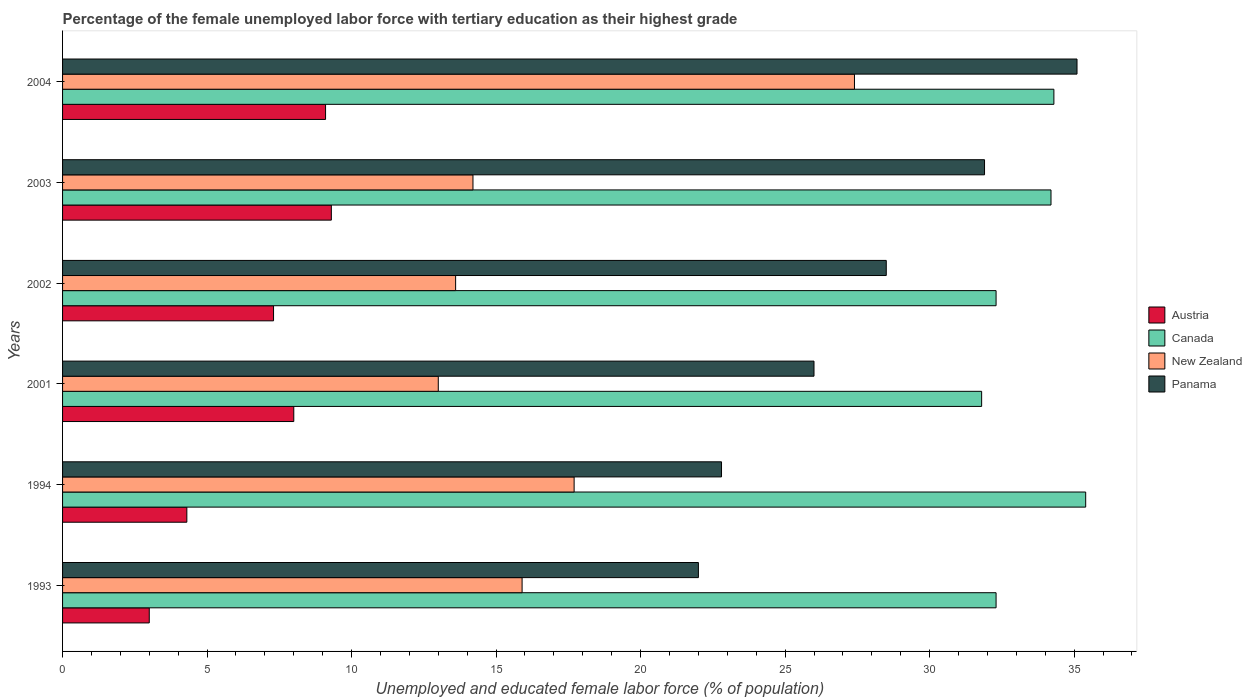How many different coloured bars are there?
Your answer should be compact. 4. Across all years, what is the maximum percentage of the unemployed female labor force with tertiary education in Canada?
Give a very brief answer. 35.4. What is the total percentage of the unemployed female labor force with tertiary education in Austria in the graph?
Offer a terse response. 41. What is the difference between the percentage of the unemployed female labor force with tertiary education in Austria in 2004 and the percentage of the unemployed female labor force with tertiary education in New Zealand in 1994?
Keep it short and to the point. -8.6. What is the average percentage of the unemployed female labor force with tertiary education in Austria per year?
Your response must be concise. 6.83. In the year 1993, what is the difference between the percentage of the unemployed female labor force with tertiary education in Panama and percentage of the unemployed female labor force with tertiary education in Canada?
Ensure brevity in your answer.  -10.3. In how many years, is the percentage of the unemployed female labor force with tertiary education in Austria greater than 18 %?
Provide a short and direct response. 0. What is the ratio of the percentage of the unemployed female labor force with tertiary education in Austria in 2002 to that in 2003?
Your response must be concise. 0.78. Is the percentage of the unemployed female labor force with tertiary education in New Zealand in 2001 less than that in 2002?
Ensure brevity in your answer.  Yes. What is the difference between the highest and the second highest percentage of the unemployed female labor force with tertiary education in Austria?
Your response must be concise. 0.2. What is the difference between the highest and the lowest percentage of the unemployed female labor force with tertiary education in Austria?
Provide a short and direct response. 6.3. Is it the case that in every year, the sum of the percentage of the unemployed female labor force with tertiary education in New Zealand and percentage of the unemployed female labor force with tertiary education in Panama is greater than the sum of percentage of the unemployed female labor force with tertiary education in Austria and percentage of the unemployed female labor force with tertiary education in Canada?
Offer a very short reply. No. What does the 1st bar from the bottom in 2002 represents?
Make the answer very short. Austria. Is it the case that in every year, the sum of the percentage of the unemployed female labor force with tertiary education in Canada and percentage of the unemployed female labor force with tertiary education in Panama is greater than the percentage of the unemployed female labor force with tertiary education in Austria?
Your response must be concise. Yes. How many bars are there?
Offer a terse response. 24. Are all the bars in the graph horizontal?
Your answer should be very brief. Yes. What is the difference between two consecutive major ticks on the X-axis?
Provide a short and direct response. 5. What is the title of the graph?
Offer a very short reply. Percentage of the female unemployed labor force with tertiary education as their highest grade. Does "Nicaragua" appear as one of the legend labels in the graph?
Give a very brief answer. No. What is the label or title of the X-axis?
Give a very brief answer. Unemployed and educated female labor force (% of population). What is the Unemployed and educated female labor force (% of population) of Canada in 1993?
Keep it short and to the point. 32.3. What is the Unemployed and educated female labor force (% of population) of New Zealand in 1993?
Keep it short and to the point. 15.9. What is the Unemployed and educated female labor force (% of population) of Austria in 1994?
Provide a succinct answer. 4.3. What is the Unemployed and educated female labor force (% of population) in Canada in 1994?
Ensure brevity in your answer.  35.4. What is the Unemployed and educated female labor force (% of population) of New Zealand in 1994?
Provide a succinct answer. 17.7. What is the Unemployed and educated female labor force (% of population) of Panama in 1994?
Ensure brevity in your answer.  22.8. What is the Unemployed and educated female labor force (% of population) in Austria in 2001?
Your answer should be compact. 8. What is the Unemployed and educated female labor force (% of population) in Canada in 2001?
Your answer should be compact. 31.8. What is the Unemployed and educated female labor force (% of population) of Austria in 2002?
Provide a succinct answer. 7.3. What is the Unemployed and educated female labor force (% of population) in Canada in 2002?
Give a very brief answer. 32.3. What is the Unemployed and educated female labor force (% of population) of New Zealand in 2002?
Give a very brief answer. 13.6. What is the Unemployed and educated female labor force (% of population) in Austria in 2003?
Your answer should be very brief. 9.3. What is the Unemployed and educated female labor force (% of population) of Canada in 2003?
Give a very brief answer. 34.2. What is the Unemployed and educated female labor force (% of population) in New Zealand in 2003?
Make the answer very short. 14.2. What is the Unemployed and educated female labor force (% of population) in Panama in 2003?
Provide a succinct answer. 31.9. What is the Unemployed and educated female labor force (% of population) of Austria in 2004?
Offer a very short reply. 9.1. What is the Unemployed and educated female labor force (% of population) of Canada in 2004?
Your answer should be very brief. 34.3. What is the Unemployed and educated female labor force (% of population) of New Zealand in 2004?
Make the answer very short. 27.4. What is the Unemployed and educated female labor force (% of population) in Panama in 2004?
Give a very brief answer. 35.1. Across all years, what is the maximum Unemployed and educated female labor force (% of population) in Austria?
Your response must be concise. 9.3. Across all years, what is the maximum Unemployed and educated female labor force (% of population) of Canada?
Make the answer very short. 35.4. Across all years, what is the maximum Unemployed and educated female labor force (% of population) in New Zealand?
Offer a very short reply. 27.4. Across all years, what is the maximum Unemployed and educated female labor force (% of population) in Panama?
Offer a very short reply. 35.1. Across all years, what is the minimum Unemployed and educated female labor force (% of population) of Austria?
Offer a terse response. 3. Across all years, what is the minimum Unemployed and educated female labor force (% of population) in Canada?
Your response must be concise. 31.8. Across all years, what is the minimum Unemployed and educated female labor force (% of population) in New Zealand?
Offer a terse response. 13. What is the total Unemployed and educated female labor force (% of population) in Canada in the graph?
Your answer should be compact. 200.3. What is the total Unemployed and educated female labor force (% of population) in New Zealand in the graph?
Your answer should be very brief. 101.8. What is the total Unemployed and educated female labor force (% of population) in Panama in the graph?
Your answer should be compact. 166.3. What is the difference between the Unemployed and educated female labor force (% of population) in Canada in 1993 and that in 1994?
Make the answer very short. -3.1. What is the difference between the Unemployed and educated female labor force (% of population) in New Zealand in 1993 and that in 1994?
Provide a short and direct response. -1.8. What is the difference between the Unemployed and educated female labor force (% of population) of Panama in 1993 and that in 1994?
Ensure brevity in your answer.  -0.8. What is the difference between the Unemployed and educated female labor force (% of population) of Canada in 1993 and that in 2001?
Your answer should be compact. 0.5. What is the difference between the Unemployed and educated female labor force (% of population) of Austria in 1993 and that in 2003?
Keep it short and to the point. -6.3. What is the difference between the Unemployed and educated female labor force (% of population) in Canada in 1993 and that in 2003?
Provide a short and direct response. -1.9. What is the difference between the Unemployed and educated female labor force (% of population) of Austria in 1993 and that in 2004?
Your response must be concise. -6.1. What is the difference between the Unemployed and educated female labor force (% of population) of Canada in 1993 and that in 2004?
Provide a succinct answer. -2. What is the difference between the Unemployed and educated female labor force (% of population) of New Zealand in 1993 and that in 2004?
Provide a succinct answer. -11.5. What is the difference between the Unemployed and educated female labor force (% of population) in Austria in 1994 and that in 2001?
Your answer should be very brief. -3.7. What is the difference between the Unemployed and educated female labor force (% of population) in Canada in 1994 and that in 2001?
Your answer should be very brief. 3.6. What is the difference between the Unemployed and educated female labor force (% of population) in New Zealand in 1994 and that in 2001?
Offer a very short reply. 4.7. What is the difference between the Unemployed and educated female labor force (% of population) of Canada in 1994 and that in 2002?
Provide a short and direct response. 3.1. What is the difference between the Unemployed and educated female labor force (% of population) of Austria in 1994 and that in 2003?
Offer a terse response. -5. What is the difference between the Unemployed and educated female labor force (% of population) of Canada in 1994 and that in 2003?
Keep it short and to the point. 1.2. What is the difference between the Unemployed and educated female labor force (% of population) in New Zealand in 1994 and that in 2003?
Offer a very short reply. 3.5. What is the difference between the Unemployed and educated female labor force (% of population) of Panama in 1994 and that in 2004?
Your answer should be compact. -12.3. What is the difference between the Unemployed and educated female labor force (% of population) of Panama in 2001 and that in 2002?
Offer a terse response. -2.5. What is the difference between the Unemployed and educated female labor force (% of population) of New Zealand in 2001 and that in 2003?
Make the answer very short. -1.2. What is the difference between the Unemployed and educated female labor force (% of population) of Panama in 2001 and that in 2003?
Your response must be concise. -5.9. What is the difference between the Unemployed and educated female labor force (% of population) of New Zealand in 2001 and that in 2004?
Your answer should be compact. -14.4. What is the difference between the Unemployed and educated female labor force (% of population) of Austria in 2002 and that in 2003?
Offer a very short reply. -2. What is the difference between the Unemployed and educated female labor force (% of population) of Canada in 2002 and that in 2003?
Your response must be concise. -1.9. What is the difference between the Unemployed and educated female labor force (% of population) of Panama in 2002 and that in 2003?
Provide a short and direct response. -3.4. What is the difference between the Unemployed and educated female labor force (% of population) of Austria in 2003 and that in 2004?
Offer a terse response. 0.2. What is the difference between the Unemployed and educated female labor force (% of population) of Canada in 2003 and that in 2004?
Your answer should be very brief. -0.1. What is the difference between the Unemployed and educated female labor force (% of population) of New Zealand in 2003 and that in 2004?
Offer a terse response. -13.2. What is the difference between the Unemployed and educated female labor force (% of population) in Austria in 1993 and the Unemployed and educated female labor force (% of population) in Canada in 1994?
Ensure brevity in your answer.  -32.4. What is the difference between the Unemployed and educated female labor force (% of population) in Austria in 1993 and the Unemployed and educated female labor force (% of population) in New Zealand in 1994?
Provide a succinct answer. -14.7. What is the difference between the Unemployed and educated female labor force (% of population) in Austria in 1993 and the Unemployed and educated female labor force (% of population) in Panama in 1994?
Make the answer very short. -19.8. What is the difference between the Unemployed and educated female labor force (% of population) in Canada in 1993 and the Unemployed and educated female labor force (% of population) in Panama in 1994?
Your answer should be very brief. 9.5. What is the difference between the Unemployed and educated female labor force (% of population) of Austria in 1993 and the Unemployed and educated female labor force (% of population) of Canada in 2001?
Provide a short and direct response. -28.8. What is the difference between the Unemployed and educated female labor force (% of population) in Austria in 1993 and the Unemployed and educated female labor force (% of population) in Panama in 2001?
Your response must be concise. -23. What is the difference between the Unemployed and educated female labor force (% of population) of Canada in 1993 and the Unemployed and educated female labor force (% of population) of New Zealand in 2001?
Offer a terse response. 19.3. What is the difference between the Unemployed and educated female labor force (% of population) in Canada in 1993 and the Unemployed and educated female labor force (% of population) in Panama in 2001?
Give a very brief answer. 6.3. What is the difference between the Unemployed and educated female labor force (% of population) in Austria in 1993 and the Unemployed and educated female labor force (% of population) in Canada in 2002?
Provide a succinct answer. -29.3. What is the difference between the Unemployed and educated female labor force (% of population) of Austria in 1993 and the Unemployed and educated female labor force (% of population) of New Zealand in 2002?
Your answer should be compact. -10.6. What is the difference between the Unemployed and educated female labor force (% of population) in Austria in 1993 and the Unemployed and educated female labor force (% of population) in Panama in 2002?
Offer a very short reply. -25.5. What is the difference between the Unemployed and educated female labor force (% of population) in New Zealand in 1993 and the Unemployed and educated female labor force (% of population) in Panama in 2002?
Keep it short and to the point. -12.6. What is the difference between the Unemployed and educated female labor force (% of population) in Austria in 1993 and the Unemployed and educated female labor force (% of population) in Canada in 2003?
Provide a succinct answer. -31.2. What is the difference between the Unemployed and educated female labor force (% of population) in Austria in 1993 and the Unemployed and educated female labor force (% of population) in Panama in 2003?
Keep it short and to the point. -28.9. What is the difference between the Unemployed and educated female labor force (% of population) of Austria in 1993 and the Unemployed and educated female labor force (% of population) of Canada in 2004?
Your answer should be compact. -31.3. What is the difference between the Unemployed and educated female labor force (% of population) in Austria in 1993 and the Unemployed and educated female labor force (% of population) in New Zealand in 2004?
Your answer should be compact. -24.4. What is the difference between the Unemployed and educated female labor force (% of population) in Austria in 1993 and the Unemployed and educated female labor force (% of population) in Panama in 2004?
Your answer should be compact. -32.1. What is the difference between the Unemployed and educated female labor force (% of population) in Canada in 1993 and the Unemployed and educated female labor force (% of population) in New Zealand in 2004?
Your answer should be compact. 4.9. What is the difference between the Unemployed and educated female labor force (% of population) in New Zealand in 1993 and the Unemployed and educated female labor force (% of population) in Panama in 2004?
Make the answer very short. -19.2. What is the difference between the Unemployed and educated female labor force (% of population) in Austria in 1994 and the Unemployed and educated female labor force (% of population) in Canada in 2001?
Offer a very short reply. -27.5. What is the difference between the Unemployed and educated female labor force (% of population) of Austria in 1994 and the Unemployed and educated female labor force (% of population) of Panama in 2001?
Ensure brevity in your answer.  -21.7. What is the difference between the Unemployed and educated female labor force (% of population) in Canada in 1994 and the Unemployed and educated female labor force (% of population) in New Zealand in 2001?
Offer a terse response. 22.4. What is the difference between the Unemployed and educated female labor force (% of population) of New Zealand in 1994 and the Unemployed and educated female labor force (% of population) of Panama in 2001?
Offer a terse response. -8.3. What is the difference between the Unemployed and educated female labor force (% of population) of Austria in 1994 and the Unemployed and educated female labor force (% of population) of New Zealand in 2002?
Offer a terse response. -9.3. What is the difference between the Unemployed and educated female labor force (% of population) in Austria in 1994 and the Unemployed and educated female labor force (% of population) in Panama in 2002?
Keep it short and to the point. -24.2. What is the difference between the Unemployed and educated female labor force (% of population) in Canada in 1994 and the Unemployed and educated female labor force (% of population) in New Zealand in 2002?
Offer a very short reply. 21.8. What is the difference between the Unemployed and educated female labor force (% of population) of Canada in 1994 and the Unemployed and educated female labor force (% of population) of Panama in 2002?
Your response must be concise. 6.9. What is the difference between the Unemployed and educated female labor force (% of population) of Austria in 1994 and the Unemployed and educated female labor force (% of population) of Canada in 2003?
Provide a succinct answer. -29.9. What is the difference between the Unemployed and educated female labor force (% of population) of Austria in 1994 and the Unemployed and educated female labor force (% of population) of Panama in 2003?
Your answer should be very brief. -27.6. What is the difference between the Unemployed and educated female labor force (% of population) in Canada in 1994 and the Unemployed and educated female labor force (% of population) in New Zealand in 2003?
Ensure brevity in your answer.  21.2. What is the difference between the Unemployed and educated female labor force (% of population) in Canada in 1994 and the Unemployed and educated female labor force (% of population) in Panama in 2003?
Offer a very short reply. 3.5. What is the difference between the Unemployed and educated female labor force (% of population) of Austria in 1994 and the Unemployed and educated female labor force (% of population) of New Zealand in 2004?
Your answer should be very brief. -23.1. What is the difference between the Unemployed and educated female labor force (% of population) of Austria in 1994 and the Unemployed and educated female labor force (% of population) of Panama in 2004?
Your answer should be compact. -30.8. What is the difference between the Unemployed and educated female labor force (% of population) in Canada in 1994 and the Unemployed and educated female labor force (% of population) in Panama in 2004?
Ensure brevity in your answer.  0.3. What is the difference between the Unemployed and educated female labor force (% of population) of New Zealand in 1994 and the Unemployed and educated female labor force (% of population) of Panama in 2004?
Provide a succinct answer. -17.4. What is the difference between the Unemployed and educated female labor force (% of population) of Austria in 2001 and the Unemployed and educated female labor force (% of population) of Canada in 2002?
Your response must be concise. -24.3. What is the difference between the Unemployed and educated female labor force (% of population) in Austria in 2001 and the Unemployed and educated female labor force (% of population) in Panama in 2002?
Your answer should be compact. -20.5. What is the difference between the Unemployed and educated female labor force (% of population) in Canada in 2001 and the Unemployed and educated female labor force (% of population) in Panama in 2002?
Make the answer very short. 3.3. What is the difference between the Unemployed and educated female labor force (% of population) in New Zealand in 2001 and the Unemployed and educated female labor force (% of population) in Panama in 2002?
Ensure brevity in your answer.  -15.5. What is the difference between the Unemployed and educated female labor force (% of population) in Austria in 2001 and the Unemployed and educated female labor force (% of population) in Canada in 2003?
Provide a succinct answer. -26.2. What is the difference between the Unemployed and educated female labor force (% of population) in Austria in 2001 and the Unemployed and educated female labor force (% of population) in New Zealand in 2003?
Your response must be concise. -6.2. What is the difference between the Unemployed and educated female labor force (% of population) of Austria in 2001 and the Unemployed and educated female labor force (% of population) of Panama in 2003?
Offer a terse response. -23.9. What is the difference between the Unemployed and educated female labor force (% of population) of Canada in 2001 and the Unemployed and educated female labor force (% of population) of New Zealand in 2003?
Offer a terse response. 17.6. What is the difference between the Unemployed and educated female labor force (% of population) in New Zealand in 2001 and the Unemployed and educated female labor force (% of population) in Panama in 2003?
Your answer should be compact. -18.9. What is the difference between the Unemployed and educated female labor force (% of population) in Austria in 2001 and the Unemployed and educated female labor force (% of population) in Canada in 2004?
Ensure brevity in your answer.  -26.3. What is the difference between the Unemployed and educated female labor force (% of population) in Austria in 2001 and the Unemployed and educated female labor force (% of population) in New Zealand in 2004?
Your answer should be compact. -19.4. What is the difference between the Unemployed and educated female labor force (% of population) of Austria in 2001 and the Unemployed and educated female labor force (% of population) of Panama in 2004?
Give a very brief answer. -27.1. What is the difference between the Unemployed and educated female labor force (% of population) in Canada in 2001 and the Unemployed and educated female labor force (% of population) in Panama in 2004?
Keep it short and to the point. -3.3. What is the difference between the Unemployed and educated female labor force (% of population) in New Zealand in 2001 and the Unemployed and educated female labor force (% of population) in Panama in 2004?
Keep it short and to the point. -22.1. What is the difference between the Unemployed and educated female labor force (% of population) in Austria in 2002 and the Unemployed and educated female labor force (% of population) in Canada in 2003?
Keep it short and to the point. -26.9. What is the difference between the Unemployed and educated female labor force (% of population) of Austria in 2002 and the Unemployed and educated female labor force (% of population) of Panama in 2003?
Your answer should be very brief. -24.6. What is the difference between the Unemployed and educated female labor force (% of population) of Canada in 2002 and the Unemployed and educated female labor force (% of population) of New Zealand in 2003?
Offer a very short reply. 18.1. What is the difference between the Unemployed and educated female labor force (% of population) in New Zealand in 2002 and the Unemployed and educated female labor force (% of population) in Panama in 2003?
Ensure brevity in your answer.  -18.3. What is the difference between the Unemployed and educated female labor force (% of population) in Austria in 2002 and the Unemployed and educated female labor force (% of population) in New Zealand in 2004?
Your response must be concise. -20.1. What is the difference between the Unemployed and educated female labor force (% of population) of Austria in 2002 and the Unemployed and educated female labor force (% of population) of Panama in 2004?
Provide a succinct answer. -27.8. What is the difference between the Unemployed and educated female labor force (% of population) in Canada in 2002 and the Unemployed and educated female labor force (% of population) in Panama in 2004?
Keep it short and to the point. -2.8. What is the difference between the Unemployed and educated female labor force (% of population) of New Zealand in 2002 and the Unemployed and educated female labor force (% of population) of Panama in 2004?
Offer a terse response. -21.5. What is the difference between the Unemployed and educated female labor force (% of population) in Austria in 2003 and the Unemployed and educated female labor force (% of population) in New Zealand in 2004?
Your answer should be compact. -18.1. What is the difference between the Unemployed and educated female labor force (% of population) in Austria in 2003 and the Unemployed and educated female labor force (% of population) in Panama in 2004?
Provide a short and direct response. -25.8. What is the difference between the Unemployed and educated female labor force (% of population) of Canada in 2003 and the Unemployed and educated female labor force (% of population) of Panama in 2004?
Offer a terse response. -0.9. What is the difference between the Unemployed and educated female labor force (% of population) in New Zealand in 2003 and the Unemployed and educated female labor force (% of population) in Panama in 2004?
Your response must be concise. -20.9. What is the average Unemployed and educated female labor force (% of population) of Austria per year?
Your answer should be very brief. 6.83. What is the average Unemployed and educated female labor force (% of population) in Canada per year?
Offer a very short reply. 33.38. What is the average Unemployed and educated female labor force (% of population) of New Zealand per year?
Offer a terse response. 16.97. What is the average Unemployed and educated female labor force (% of population) of Panama per year?
Offer a terse response. 27.72. In the year 1993, what is the difference between the Unemployed and educated female labor force (% of population) in Austria and Unemployed and educated female labor force (% of population) in Canada?
Provide a short and direct response. -29.3. In the year 1993, what is the difference between the Unemployed and educated female labor force (% of population) of Canada and Unemployed and educated female labor force (% of population) of New Zealand?
Keep it short and to the point. 16.4. In the year 1993, what is the difference between the Unemployed and educated female labor force (% of population) of New Zealand and Unemployed and educated female labor force (% of population) of Panama?
Keep it short and to the point. -6.1. In the year 1994, what is the difference between the Unemployed and educated female labor force (% of population) of Austria and Unemployed and educated female labor force (% of population) of Canada?
Give a very brief answer. -31.1. In the year 1994, what is the difference between the Unemployed and educated female labor force (% of population) in Austria and Unemployed and educated female labor force (% of population) in Panama?
Make the answer very short. -18.5. In the year 1994, what is the difference between the Unemployed and educated female labor force (% of population) of Canada and Unemployed and educated female labor force (% of population) of Panama?
Your answer should be compact. 12.6. In the year 2001, what is the difference between the Unemployed and educated female labor force (% of population) in Austria and Unemployed and educated female labor force (% of population) in Canada?
Give a very brief answer. -23.8. In the year 2001, what is the difference between the Unemployed and educated female labor force (% of population) in Austria and Unemployed and educated female labor force (% of population) in Panama?
Make the answer very short. -18. In the year 2001, what is the difference between the Unemployed and educated female labor force (% of population) of Canada and Unemployed and educated female labor force (% of population) of New Zealand?
Your answer should be compact. 18.8. In the year 2001, what is the difference between the Unemployed and educated female labor force (% of population) of New Zealand and Unemployed and educated female labor force (% of population) of Panama?
Give a very brief answer. -13. In the year 2002, what is the difference between the Unemployed and educated female labor force (% of population) in Austria and Unemployed and educated female labor force (% of population) in Canada?
Give a very brief answer. -25. In the year 2002, what is the difference between the Unemployed and educated female labor force (% of population) in Austria and Unemployed and educated female labor force (% of population) in Panama?
Your answer should be very brief. -21.2. In the year 2002, what is the difference between the Unemployed and educated female labor force (% of population) of New Zealand and Unemployed and educated female labor force (% of population) of Panama?
Your response must be concise. -14.9. In the year 2003, what is the difference between the Unemployed and educated female labor force (% of population) of Austria and Unemployed and educated female labor force (% of population) of Canada?
Provide a succinct answer. -24.9. In the year 2003, what is the difference between the Unemployed and educated female labor force (% of population) in Austria and Unemployed and educated female labor force (% of population) in Panama?
Your answer should be very brief. -22.6. In the year 2003, what is the difference between the Unemployed and educated female labor force (% of population) of New Zealand and Unemployed and educated female labor force (% of population) of Panama?
Make the answer very short. -17.7. In the year 2004, what is the difference between the Unemployed and educated female labor force (% of population) of Austria and Unemployed and educated female labor force (% of population) of Canada?
Ensure brevity in your answer.  -25.2. In the year 2004, what is the difference between the Unemployed and educated female labor force (% of population) of Austria and Unemployed and educated female labor force (% of population) of New Zealand?
Provide a short and direct response. -18.3. In the year 2004, what is the difference between the Unemployed and educated female labor force (% of population) of Austria and Unemployed and educated female labor force (% of population) of Panama?
Provide a short and direct response. -26. In the year 2004, what is the difference between the Unemployed and educated female labor force (% of population) in Canada and Unemployed and educated female labor force (% of population) in New Zealand?
Make the answer very short. 6.9. In the year 2004, what is the difference between the Unemployed and educated female labor force (% of population) of Canada and Unemployed and educated female labor force (% of population) of Panama?
Ensure brevity in your answer.  -0.8. In the year 2004, what is the difference between the Unemployed and educated female labor force (% of population) of New Zealand and Unemployed and educated female labor force (% of population) of Panama?
Provide a short and direct response. -7.7. What is the ratio of the Unemployed and educated female labor force (% of population) in Austria in 1993 to that in 1994?
Provide a short and direct response. 0.7. What is the ratio of the Unemployed and educated female labor force (% of population) of Canada in 1993 to that in 1994?
Keep it short and to the point. 0.91. What is the ratio of the Unemployed and educated female labor force (% of population) of New Zealand in 1993 to that in 1994?
Your answer should be very brief. 0.9. What is the ratio of the Unemployed and educated female labor force (% of population) of Panama in 1993 to that in 1994?
Keep it short and to the point. 0.96. What is the ratio of the Unemployed and educated female labor force (% of population) in Canada in 1993 to that in 2001?
Ensure brevity in your answer.  1.02. What is the ratio of the Unemployed and educated female labor force (% of population) of New Zealand in 1993 to that in 2001?
Keep it short and to the point. 1.22. What is the ratio of the Unemployed and educated female labor force (% of population) in Panama in 1993 to that in 2001?
Give a very brief answer. 0.85. What is the ratio of the Unemployed and educated female labor force (% of population) in Austria in 1993 to that in 2002?
Provide a succinct answer. 0.41. What is the ratio of the Unemployed and educated female labor force (% of population) in Canada in 1993 to that in 2002?
Your answer should be very brief. 1. What is the ratio of the Unemployed and educated female labor force (% of population) of New Zealand in 1993 to that in 2002?
Provide a succinct answer. 1.17. What is the ratio of the Unemployed and educated female labor force (% of population) of Panama in 1993 to that in 2002?
Keep it short and to the point. 0.77. What is the ratio of the Unemployed and educated female labor force (% of population) of Austria in 1993 to that in 2003?
Provide a short and direct response. 0.32. What is the ratio of the Unemployed and educated female labor force (% of population) of New Zealand in 1993 to that in 2003?
Keep it short and to the point. 1.12. What is the ratio of the Unemployed and educated female labor force (% of population) of Panama in 1993 to that in 2003?
Provide a succinct answer. 0.69. What is the ratio of the Unemployed and educated female labor force (% of population) of Austria in 1993 to that in 2004?
Give a very brief answer. 0.33. What is the ratio of the Unemployed and educated female labor force (% of population) of Canada in 1993 to that in 2004?
Your answer should be compact. 0.94. What is the ratio of the Unemployed and educated female labor force (% of population) in New Zealand in 1993 to that in 2004?
Your answer should be compact. 0.58. What is the ratio of the Unemployed and educated female labor force (% of population) of Panama in 1993 to that in 2004?
Provide a succinct answer. 0.63. What is the ratio of the Unemployed and educated female labor force (% of population) in Austria in 1994 to that in 2001?
Keep it short and to the point. 0.54. What is the ratio of the Unemployed and educated female labor force (% of population) in Canada in 1994 to that in 2001?
Your answer should be very brief. 1.11. What is the ratio of the Unemployed and educated female labor force (% of population) in New Zealand in 1994 to that in 2001?
Ensure brevity in your answer.  1.36. What is the ratio of the Unemployed and educated female labor force (% of population) in Panama in 1994 to that in 2001?
Offer a very short reply. 0.88. What is the ratio of the Unemployed and educated female labor force (% of population) in Austria in 1994 to that in 2002?
Ensure brevity in your answer.  0.59. What is the ratio of the Unemployed and educated female labor force (% of population) of Canada in 1994 to that in 2002?
Offer a very short reply. 1.1. What is the ratio of the Unemployed and educated female labor force (% of population) of New Zealand in 1994 to that in 2002?
Offer a terse response. 1.3. What is the ratio of the Unemployed and educated female labor force (% of population) in Austria in 1994 to that in 2003?
Your answer should be compact. 0.46. What is the ratio of the Unemployed and educated female labor force (% of population) of Canada in 1994 to that in 2003?
Give a very brief answer. 1.04. What is the ratio of the Unemployed and educated female labor force (% of population) of New Zealand in 1994 to that in 2003?
Your response must be concise. 1.25. What is the ratio of the Unemployed and educated female labor force (% of population) in Panama in 1994 to that in 2003?
Make the answer very short. 0.71. What is the ratio of the Unemployed and educated female labor force (% of population) in Austria in 1994 to that in 2004?
Offer a terse response. 0.47. What is the ratio of the Unemployed and educated female labor force (% of population) of Canada in 1994 to that in 2004?
Keep it short and to the point. 1.03. What is the ratio of the Unemployed and educated female labor force (% of population) of New Zealand in 1994 to that in 2004?
Ensure brevity in your answer.  0.65. What is the ratio of the Unemployed and educated female labor force (% of population) of Panama in 1994 to that in 2004?
Give a very brief answer. 0.65. What is the ratio of the Unemployed and educated female labor force (% of population) of Austria in 2001 to that in 2002?
Provide a succinct answer. 1.1. What is the ratio of the Unemployed and educated female labor force (% of population) in Canada in 2001 to that in 2002?
Your response must be concise. 0.98. What is the ratio of the Unemployed and educated female labor force (% of population) in New Zealand in 2001 to that in 2002?
Your response must be concise. 0.96. What is the ratio of the Unemployed and educated female labor force (% of population) in Panama in 2001 to that in 2002?
Offer a terse response. 0.91. What is the ratio of the Unemployed and educated female labor force (% of population) of Austria in 2001 to that in 2003?
Make the answer very short. 0.86. What is the ratio of the Unemployed and educated female labor force (% of population) in Canada in 2001 to that in 2003?
Provide a succinct answer. 0.93. What is the ratio of the Unemployed and educated female labor force (% of population) in New Zealand in 2001 to that in 2003?
Give a very brief answer. 0.92. What is the ratio of the Unemployed and educated female labor force (% of population) of Panama in 2001 to that in 2003?
Your answer should be compact. 0.81. What is the ratio of the Unemployed and educated female labor force (% of population) of Austria in 2001 to that in 2004?
Offer a very short reply. 0.88. What is the ratio of the Unemployed and educated female labor force (% of population) in Canada in 2001 to that in 2004?
Offer a very short reply. 0.93. What is the ratio of the Unemployed and educated female labor force (% of population) in New Zealand in 2001 to that in 2004?
Offer a very short reply. 0.47. What is the ratio of the Unemployed and educated female labor force (% of population) in Panama in 2001 to that in 2004?
Provide a succinct answer. 0.74. What is the ratio of the Unemployed and educated female labor force (% of population) in Austria in 2002 to that in 2003?
Offer a very short reply. 0.78. What is the ratio of the Unemployed and educated female labor force (% of population) of Canada in 2002 to that in 2003?
Ensure brevity in your answer.  0.94. What is the ratio of the Unemployed and educated female labor force (% of population) of New Zealand in 2002 to that in 2003?
Give a very brief answer. 0.96. What is the ratio of the Unemployed and educated female labor force (% of population) of Panama in 2002 to that in 2003?
Your response must be concise. 0.89. What is the ratio of the Unemployed and educated female labor force (% of population) of Austria in 2002 to that in 2004?
Your answer should be compact. 0.8. What is the ratio of the Unemployed and educated female labor force (% of population) in Canada in 2002 to that in 2004?
Provide a short and direct response. 0.94. What is the ratio of the Unemployed and educated female labor force (% of population) in New Zealand in 2002 to that in 2004?
Keep it short and to the point. 0.5. What is the ratio of the Unemployed and educated female labor force (% of population) of Panama in 2002 to that in 2004?
Make the answer very short. 0.81. What is the ratio of the Unemployed and educated female labor force (% of population) of New Zealand in 2003 to that in 2004?
Provide a succinct answer. 0.52. What is the ratio of the Unemployed and educated female labor force (% of population) in Panama in 2003 to that in 2004?
Provide a short and direct response. 0.91. What is the difference between the highest and the second highest Unemployed and educated female labor force (% of population) of Austria?
Provide a short and direct response. 0.2. What is the difference between the highest and the second highest Unemployed and educated female labor force (% of population) of Canada?
Make the answer very short. 1.1. What is the difference between the highest and the second highest Unemployed and educated female labor force (% of population) of New Zealand?
Keep it short and to the point. 9.7. What is the difference between the highest and the second highest Unemployed and educated female labor force (% of population) in Panama?
Keep it short and to the point. 3.2. What is the difference between the highest and the lowest Unemployed and educated female labor force (% of population) in Austria?
Offer a terse response. 6.3. What is the difference between the highest and the lowest Unemployed and educated female labor force (% of population) of Canada?
Your response must be concise. 3.6. What is the difference between the highest and the lowest Unemployed and educated female labor force (% of population) in New Zealand?
Offer a terse response. 14.4. What is the difference between the highest and the lowest Unemployed and educated female labor force (% of population) in Panama?
Offer a terse response. 13.1. 